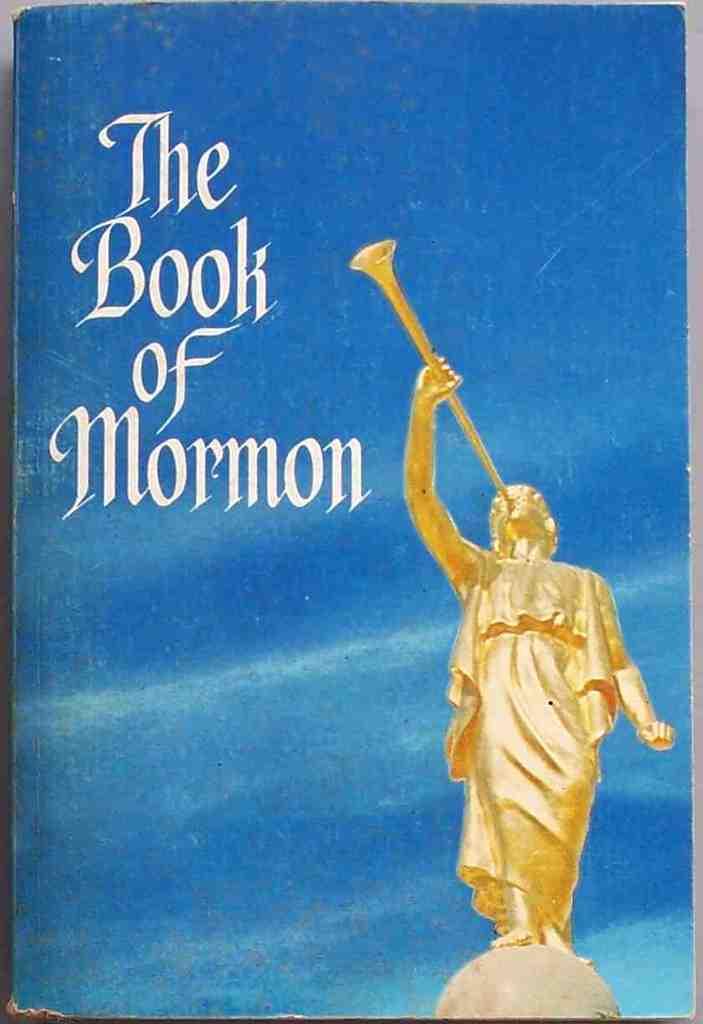What is the book title?
Make the answer very short. The book of mormon. 